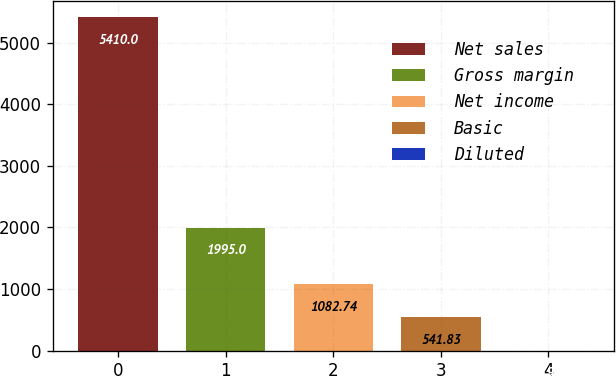Convert chart. <chart><loc_0><loc_0><loc_500><loc_500><bar_chart><fcel>Net sales<fcel>Gross margin<fcel>Net income<fcel>Basic<fcel>Diluted<nl><fcel>5410<fcel>1995<fcel>1082.74<fcel>541.83<fcel>0.92<nl></chart> 